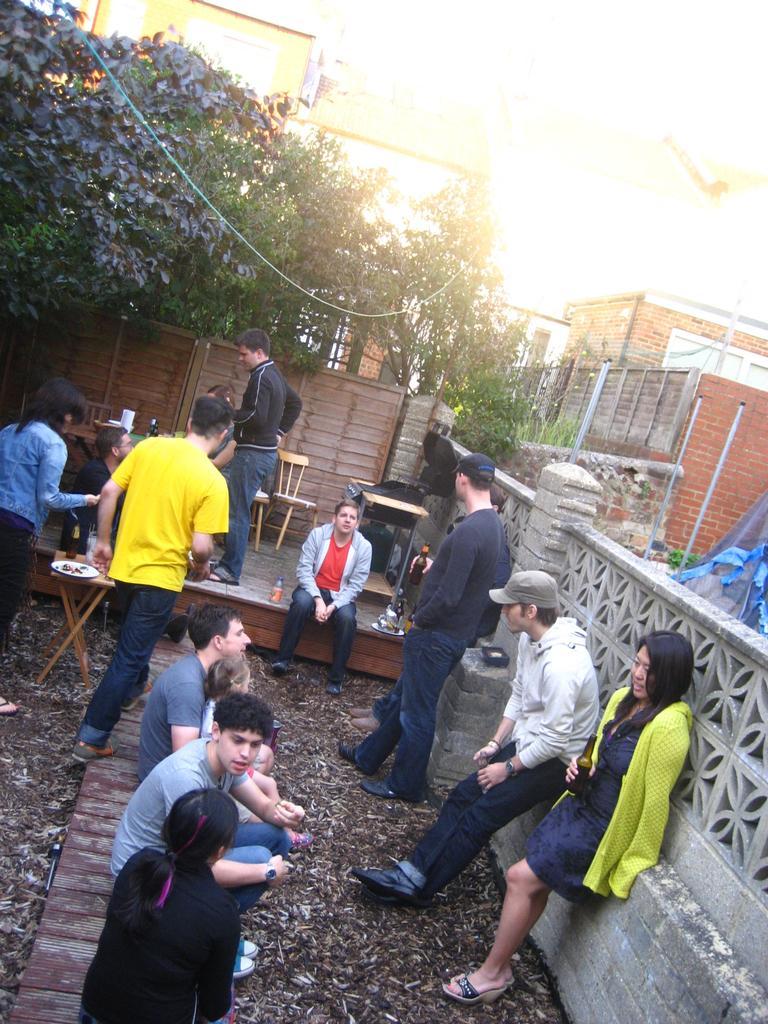Could you give a brief overview of what you see in this image? In this image we can see a group of persons. Behind the persons we can see a wall, chairs and tables. At the top we can see trees and buildings. On the right side, we can see a wall. 